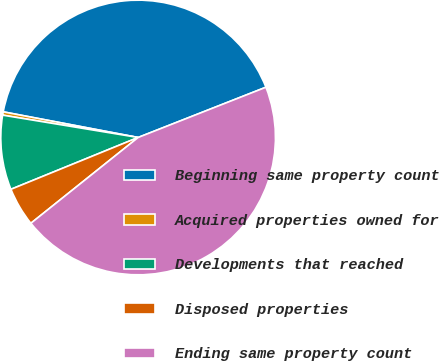Convert chart to OTSL. <chart><loc_0><loc_0><loc_500><loc_500><pie_chart><fcel>Beginning same property count<fcel>Acquired properties owned for<fcel>Developments that reached<fcel>Disposed properties<fcel>Ending same property count<nl><fcel>41.05%<fcel>0.39%<fcel>8.76%<fcel>4.58%<fcel>45.23%<nl></chart> 